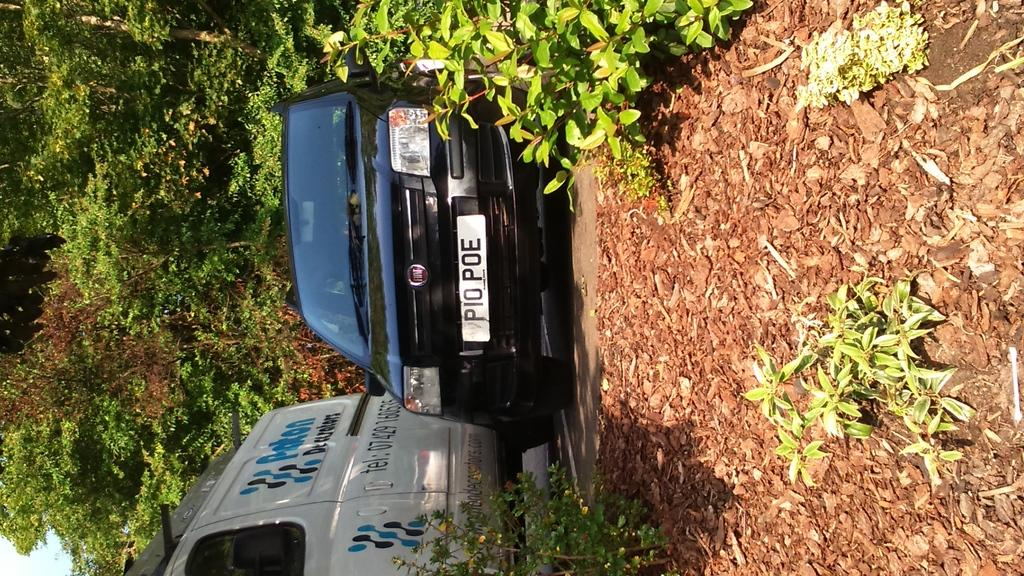How many vehicles can be seen in the image? There are two vehicles in the image. What is the location of the vehicles in the image? The vehicles are parked beside a land filled with dry leaves. What can be seen behind the vehicles in the image? There are trees visible behind the vehicles. What type of scent can be detected from the vehicles in the image? There is no information about the scent of the vehicles in the image, so it cannot be determined. 